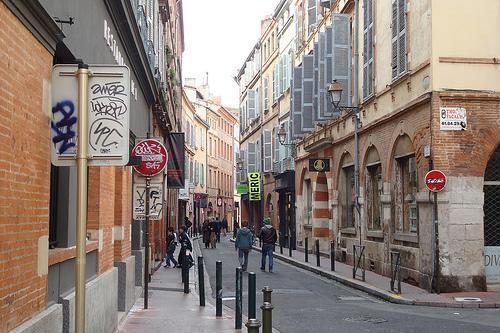How many streets are there?
Give a very brief answer. 1. 